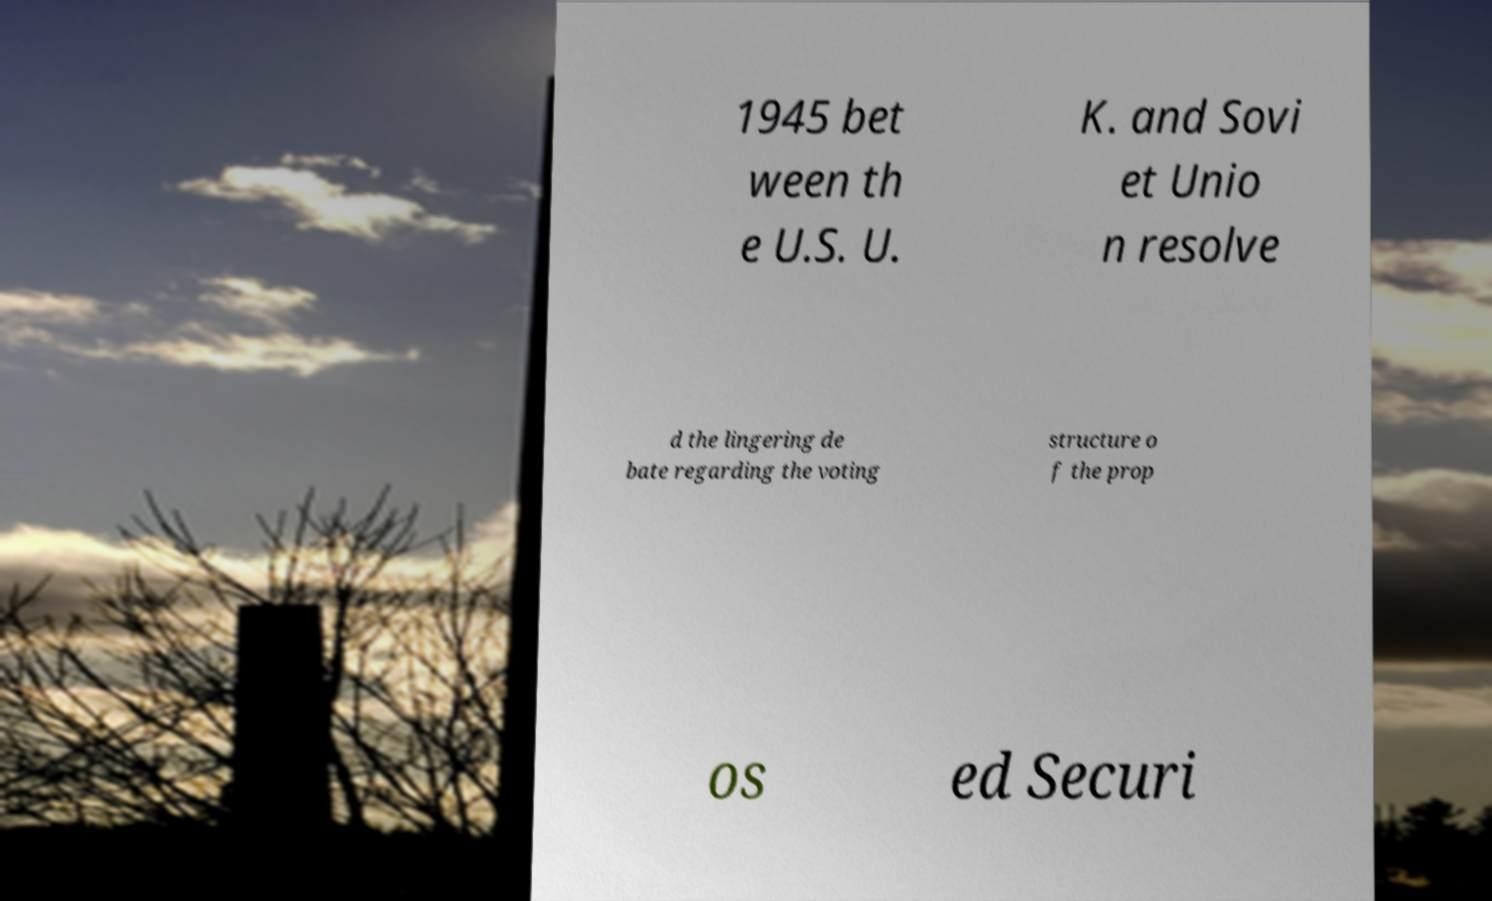What messages or text are displayed in this image? I need them in a readable, typed format. 1945 bet ween th e U.S. U. K. and Sovi et Unio n resolve d the lingering de bate regarding the voting structure o f the prop os ed Securi 